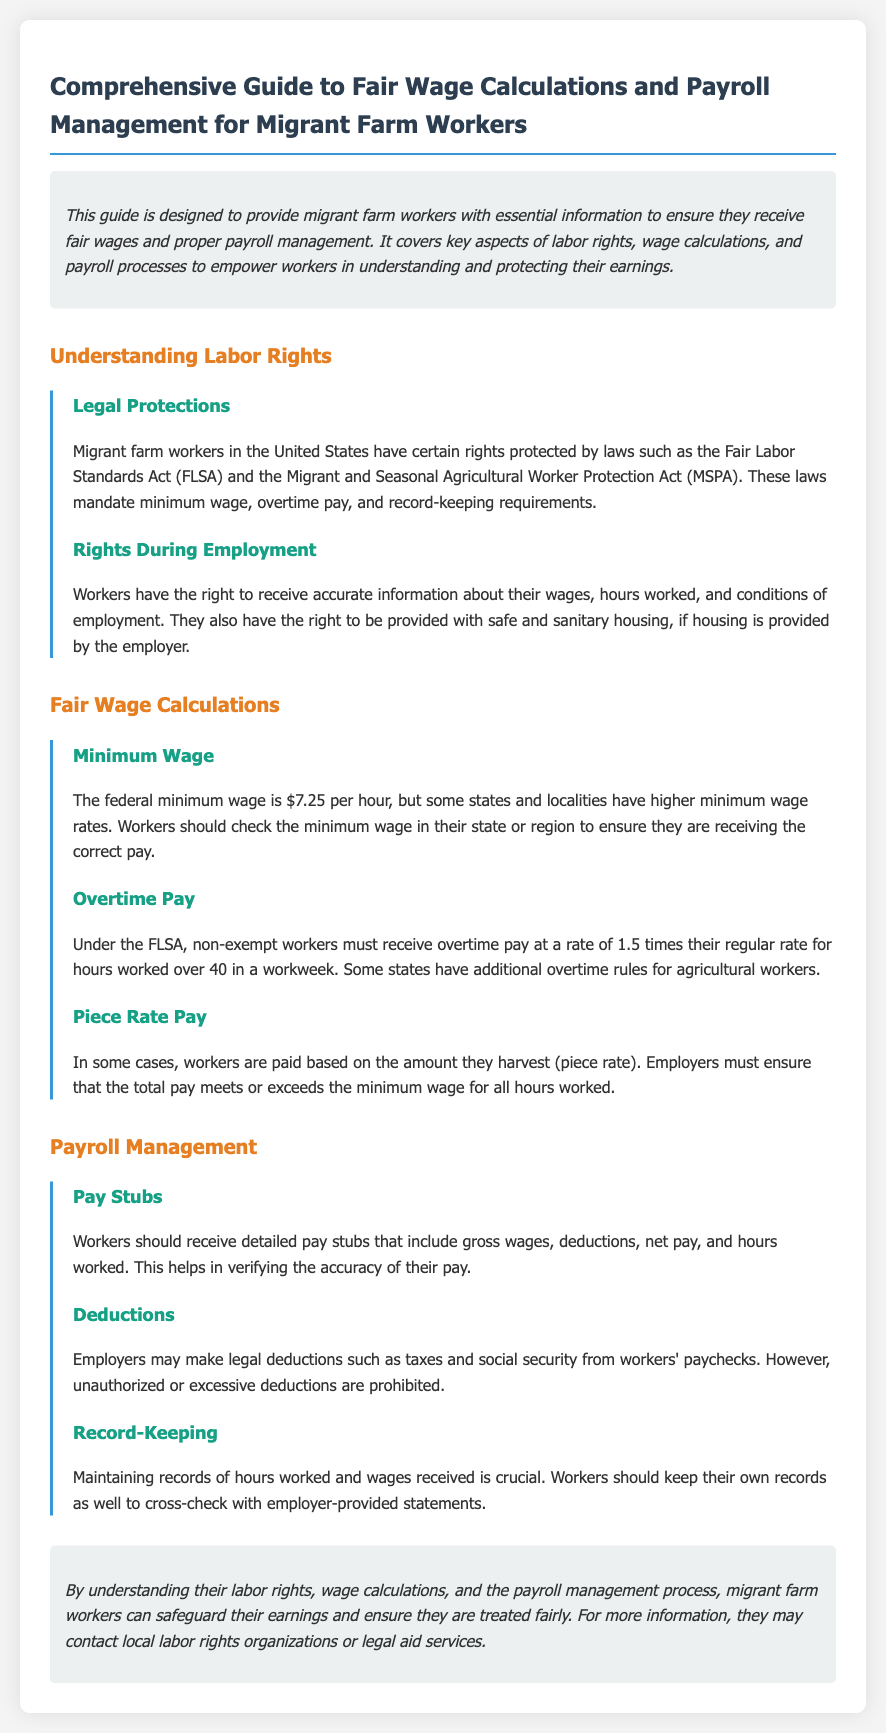What is the federal minimum wage? The document states that the federal minimum wage is $7.25 per hour.
Answer: $7.25 per hour What must non-exempt workers receive for overtime pay? According to the document, non-exempt workers must receive overtime pay at a rate of 1.5 times their regular rate for hours worked over 40 in a workweek.
Answer: 1.5 times their regular rate What acts protect the rights of migrant farm workers? The document mentions the Fair Labor Standards Act (FLSA) and the Migrant and Seasonal Agricultural Worker Protection Act (MSPA).
Answer: Fair Labor Standards Act (FLSA) and Migrant and Seasonal Agricultural Worker Protection Act (MSPA) What should be included in the pay stubs received by workers? The document specifies that pay stubs should include gross wages, deductions, net pay, and hours worked.
Answer: Gross wages, deductions, net pay, and hours worked What must be done if workers are paid on a piece rate? According to the document, employers must ensure that the total pay meets or exceeds the minimum wage for all hours worked.
Answer: Total pay meets or exceeds the minimum wage Why is it important for workers to maintain records of hours worked? The document suggests that maintaining records helps workers cross-check with employer-provided statements for accuracy.
Answer: To cross-check with employer-provided statements What should workers do if they believe their rights are being violated? The guide advises contacting local labor rights organizations or legal aid services for further information.
Answer: Contact local labor rights organizations or legal aid services What options do employers have for making deductions from paychecks? The document indicates that employers may make legal deductions such as taxes and social security, but unauthorized deductions are prohibited.
Answer: Legal deductions such as taxes and social security What kind of housing rights do workers have during employment? The document states that workers have the right to be provided with safe and sanitary housing if housing is provided by the employer.
Answer: Safe and sanitary housing What is the purpose of this guide? The document outlines that the guide is designed to provide migrant farm workers with essential information to ensure they receive fair wages and proper payroll management.
Answer: To ensure fair wages and proper payroll management 